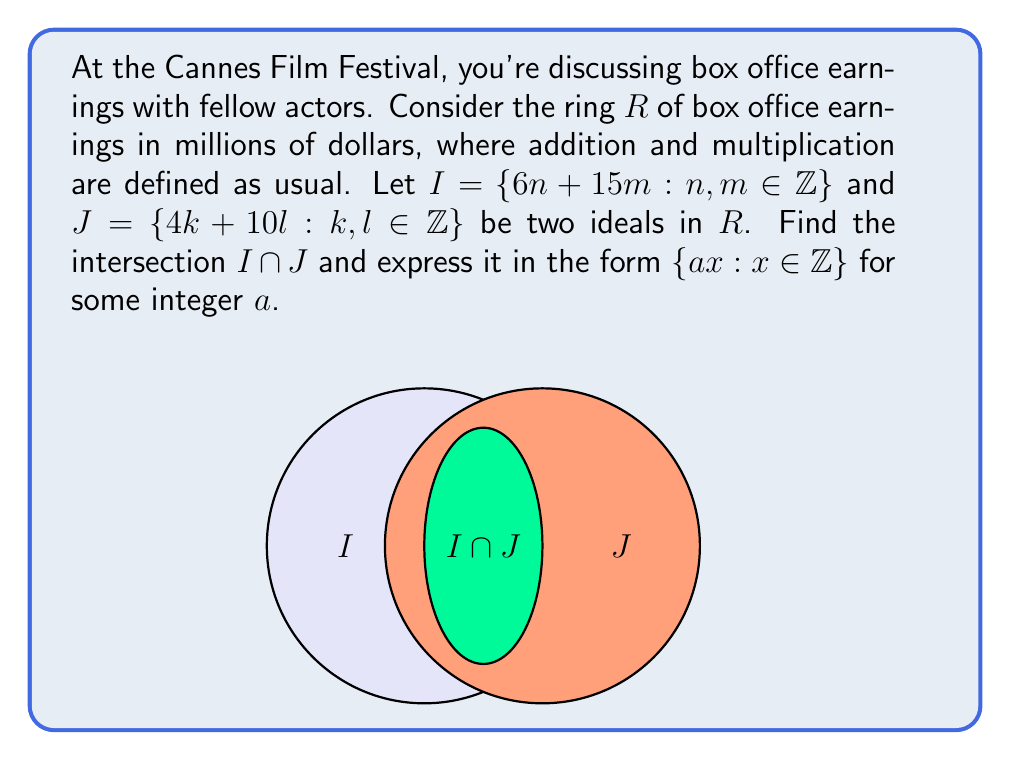What is the answer to this math problem? Let's approach this step-by-step:

1) First, we need to find a general form for elements in $I \cap J$. Any element in this intersection must be expressible in both forms:

   $$6n + 15m = 4k + 10l$$ for some integers $n, m, k, l$.

2) We can use the Euclidean algorithm to find the greatest common divisor (GCD) of the coefficients in each ideal:

   For $I$: $\gcd(6, 15) = 3$
   For $J$: $\gcd(4, 10) = 2$

3) This means that $I = \{3x : x \in \mathbb{Z}\}$ and $J = \{2y : y \in \mathbb{Z}\}$.

4) Now, for a number to be in both $I$ and $J$, it must be divisible by both 3 and 2. The least common multiple (LCM) of 3 and 2 is 6.

5) Therefore, any number in $I \cap J$ must be divisible by 6.

6) We can express this as: $I \cap J = \{6z : z \in \mathbb{Z}\}$

7) To verify, note that any multiple of 6 can be expressed in both forms:
   
   $6z = 6(z) + 15(0)$ (form for $I$)
   $6z = 4(z) + 10(\frac{z}{5})$ (form for $J$, when $z$ is divisible by 5)
   $6z = 4(z+5k) + 10(-2k)$ (form for $J$, for any integer $k$)

Thus, we have found that $a = 6$ in the required form $\{ax : x \in \mathbb{Z}\}$.
Answer: $I \cap J = \{6x : x \in \mathbb{Z}\}$ 